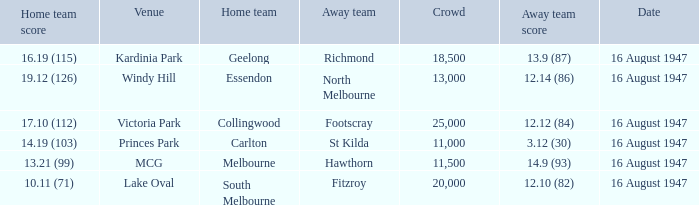Help me parse the entirety of this table. {'header': ['Home team score', 'Venue', 'Home team', 'Away team', 'Crowd', 'Away team score', 'Date'], 'rows': [['16.19 (115)', 'Kardinia Park', 'Geelong', 'Richmond', '18,500', '13.9 (87)', '16 August 1947'], ['19.12 (126)', 'Windy Hill', 'Essendon', 'North Melbourne', '13,000', '12.14 (86)', '16 August 1947'], ['17.10 (112)', 'Victoria Park', 'Collingwood', 'Footscray', '25,000', '12.12 (84)', '16 August 1947'], ['14.19 (103)', 'Princes Park', 'Carlton', 'St Kilda', '11,000', '3.12 (30)', '16 August 1947'], ['13.21 (99)', 'MCG', 'Melbourne', 'Hawthorn', '11,500', '14.9 (93)', '16 August 1947'], ['10.11 (71)', 'Lake Oval', 'South Melbourne', 'Fitzroy', '20,000', '12.10 (82)', '16 August 1947']]} What was the total size of the crowd when the away team scored 12.10 (82)? 20000.0. 